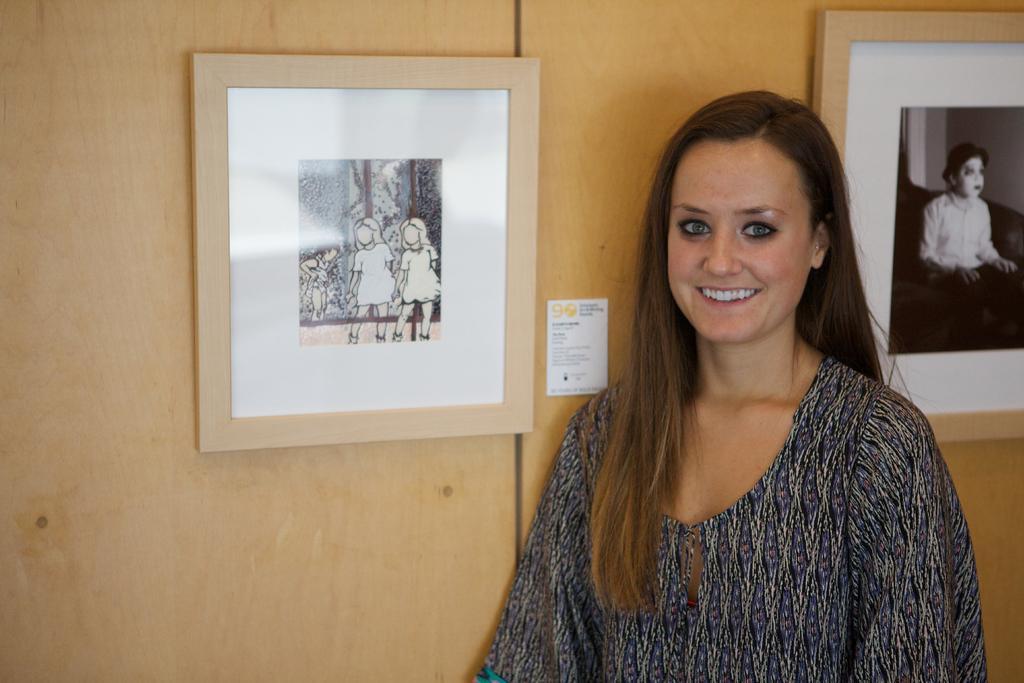How would you summarize this image in a sentence or two? In this image we can see a lady. There are two photos on the wall. There is an object on the wall. 